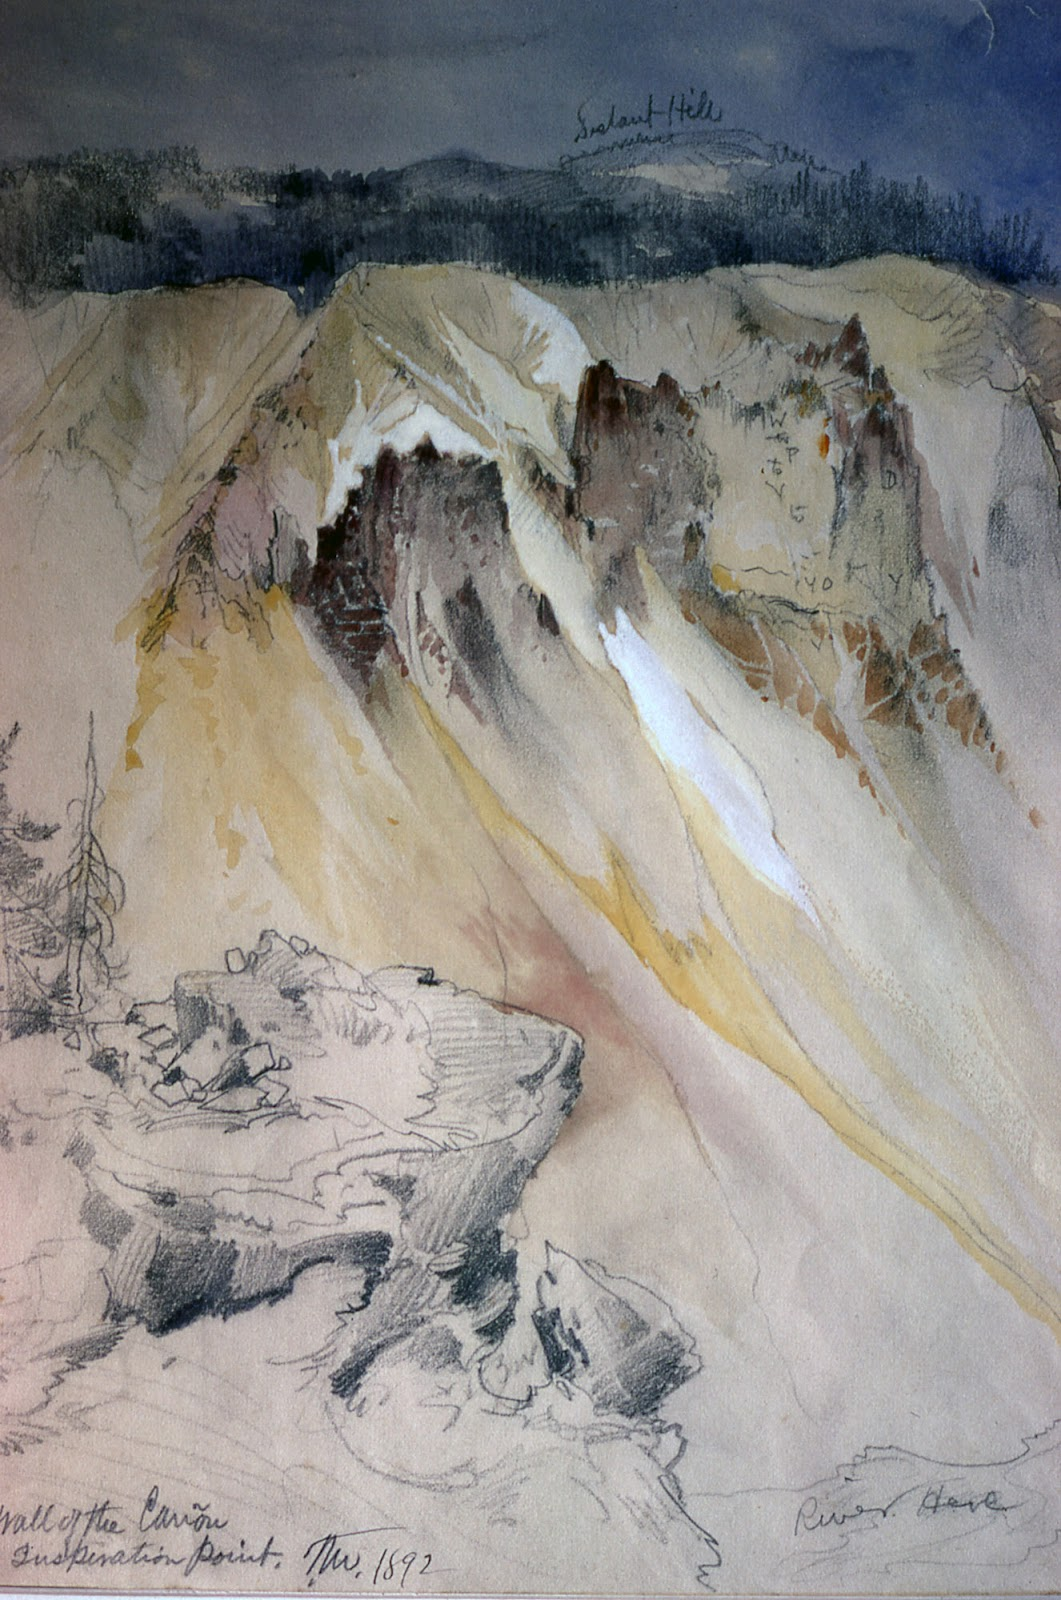Can you weave a story inspired by this landscape painting? In a distant age, long before human feet tread upon the soil, these majestic mountains were the abode of an ancient tribe of sky-dancers. They were a peaceful people, guardians of the natural world, who could call upon the elements to protect and preserve the land. Every dawn, the tribe’s matriarch would ascend to the peak where she would converse with the winds and the rivers, asking them to bless the valleys and the hills. Over time, her whispers became etched into the very stones of the canyon, markings of their ancient incantations. As the sun dipped below the horizon, an ethereal glow would awaken in the rocks, a reminder of the harmony that once existed between the earth and its ethereal keepers... 